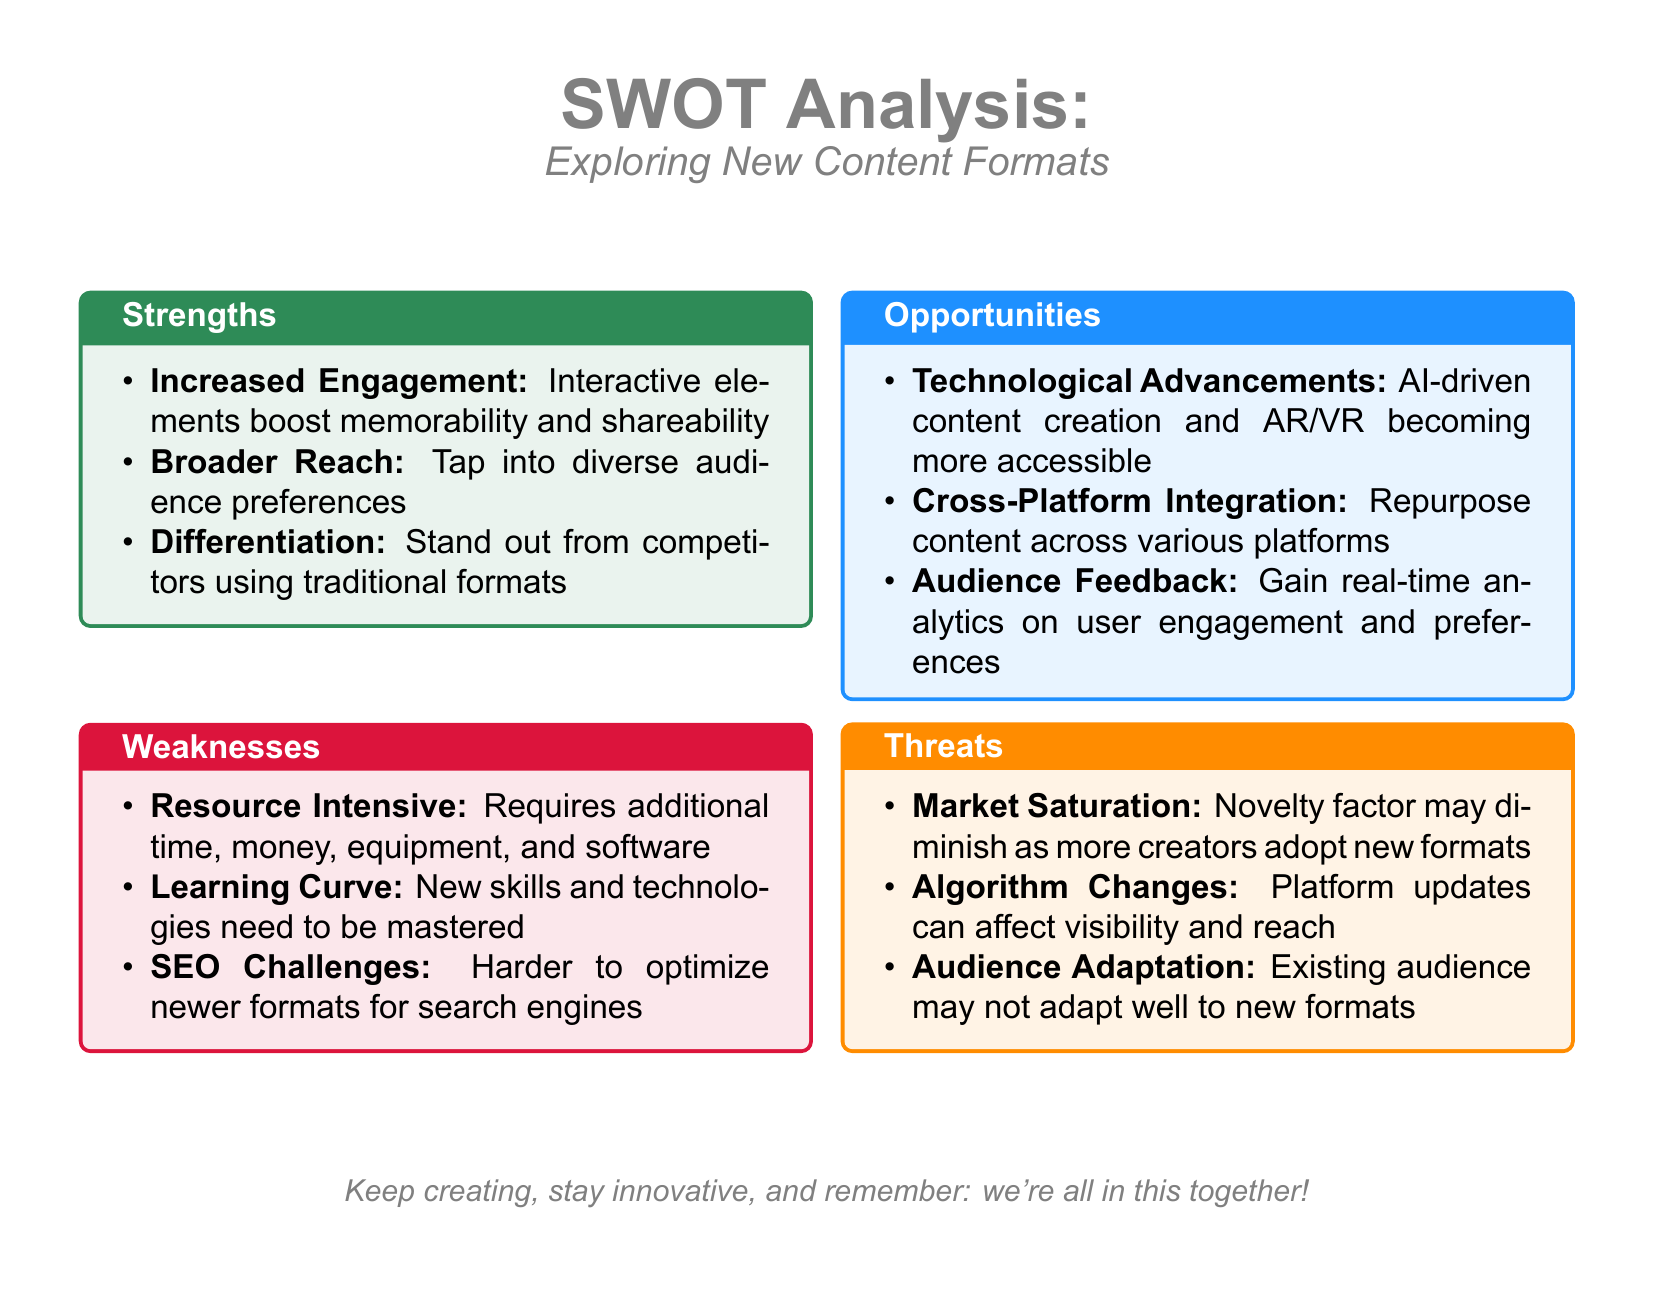What are the strengths of exploring new content formats? The strengths are listed in the Strengths section of the SWOT analysis, which includes increased engagement, broader reach, and differentiation.
Answer: Increased Engagement, Broader Reach, Differentiation What is a notable weakness associated with new content formats? The weaknesses section highlights various challenges, one notable weakness is the resource-intensive nature of new formats.
Answer: Resource Intensive How many opportunities are identified in the document? The Opportunities section lists three distinct opportunities for exploring new content formats.
Answer: 3 What threat is mentioned related to market conditions? The Threats section includes market saturation as a potential threat when exploring new content formats.
Answer: Market Saturation Which strength pertains to audience engagement? Increased engagement is specifically mentioned as a strength related to new content formats.
Answer: Increased Engagement What is a technological advancement mentioned in the opportunities? The document highlights AI-driven content creation as a significant technological advancement opportunity.
Answer: AI-driven content creation What is one possible consequence of algorithm changes according to the document? The document states that algorithm changes can affect visibility and reach, indicating this could impact content performance.
Answer: Visibility and reach What might hinder audience adaptation to new formats? The document mentions that existing audience may not adapt well as a potential threat when exploring new formats.
Answer: Existing audience may not adapt well 